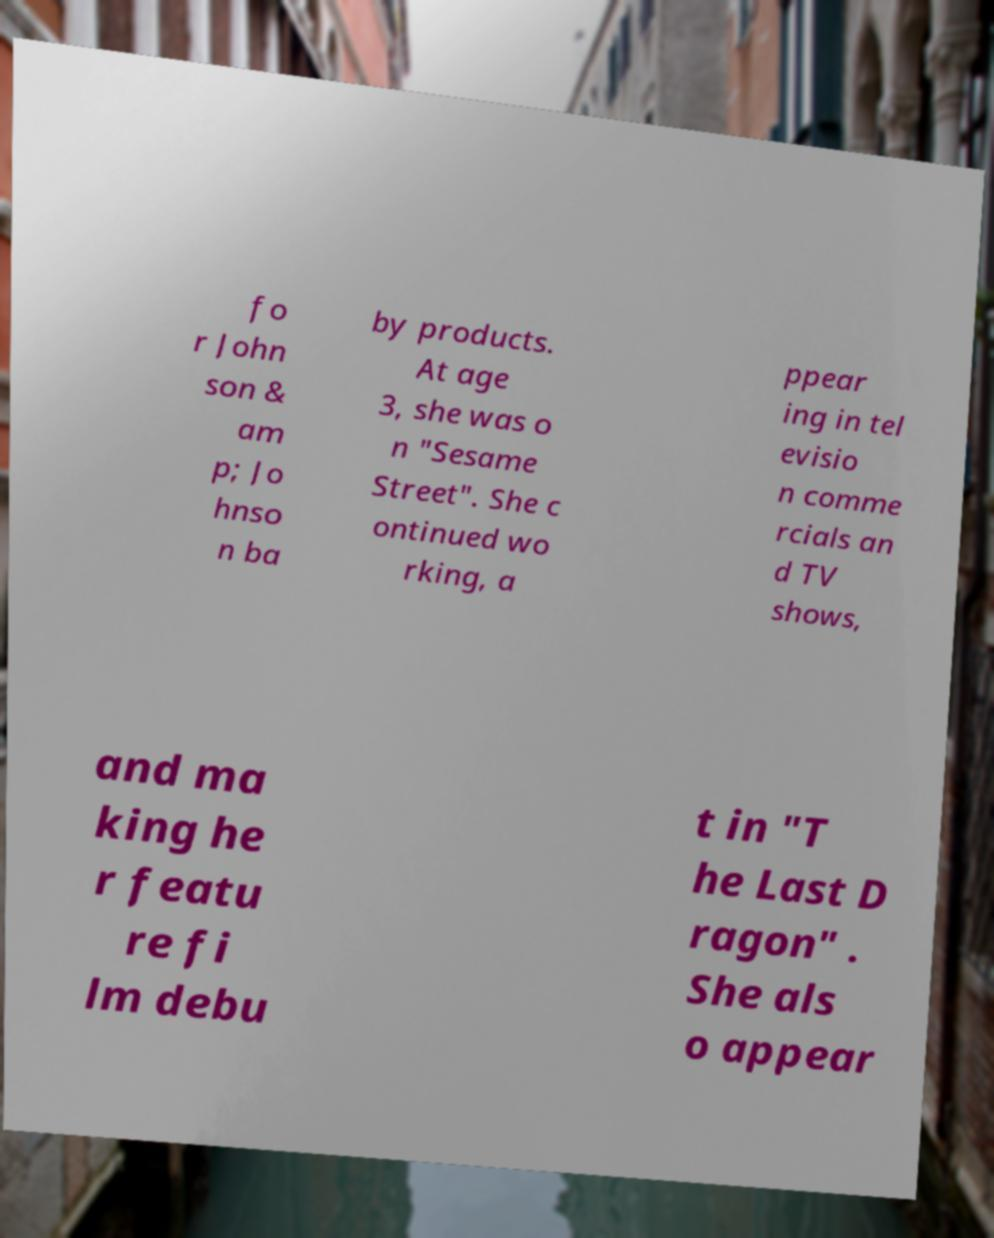There's text embedded in this image that I need extracted. Can you transcribe it verbatim? fo r John son & am p; Jo hnso n ba by products. At age 3, she was o n "Sesame Street". She c ontinued wo rking, a ppear ing in tel evisio n comme rcials an d TV shows, and ma king he r featu re fi lm debu t in "T he Last D ragon" . She als o appear 